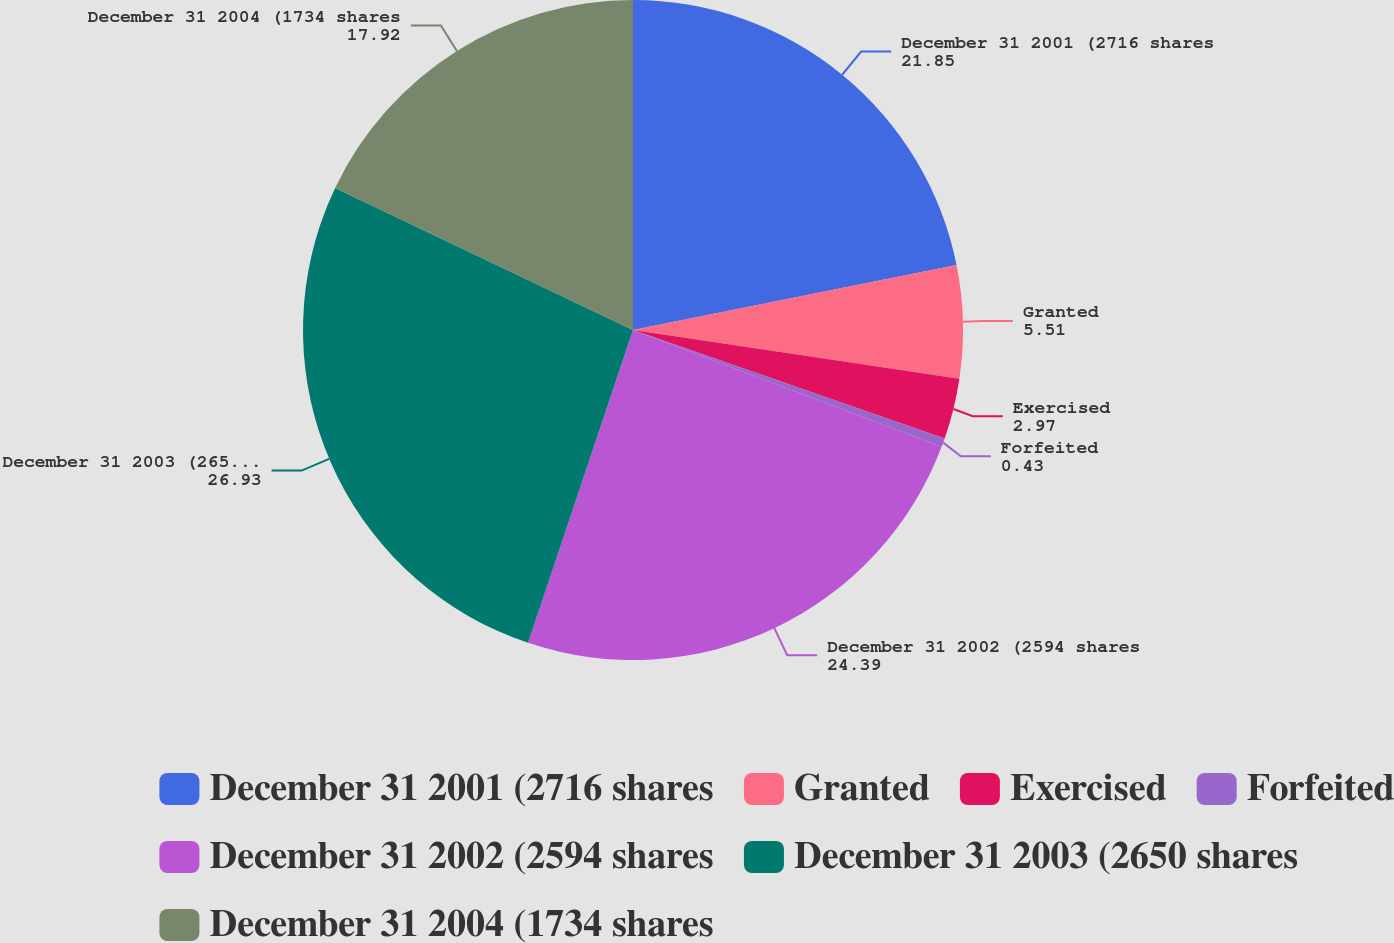<chart> <loc_0><loc_0><loc_500><loc_500><pie_chart><fcel>December 31 2001 (2716 shares<fcel>Granted<fcel>Exercised<fcel>Forfeited<fcel>December 31 2002 (2594 shares<fcel>December 31 2003 (2650 shares<fcel>December 31 2004 (1734 shares<nl><fcel>21.85%<fcel>5.51%<fcel>2.97%<fcel>0.43%<fcel>24.39%<fcel>26.93%<fcel>17.92%<nl></chart> 